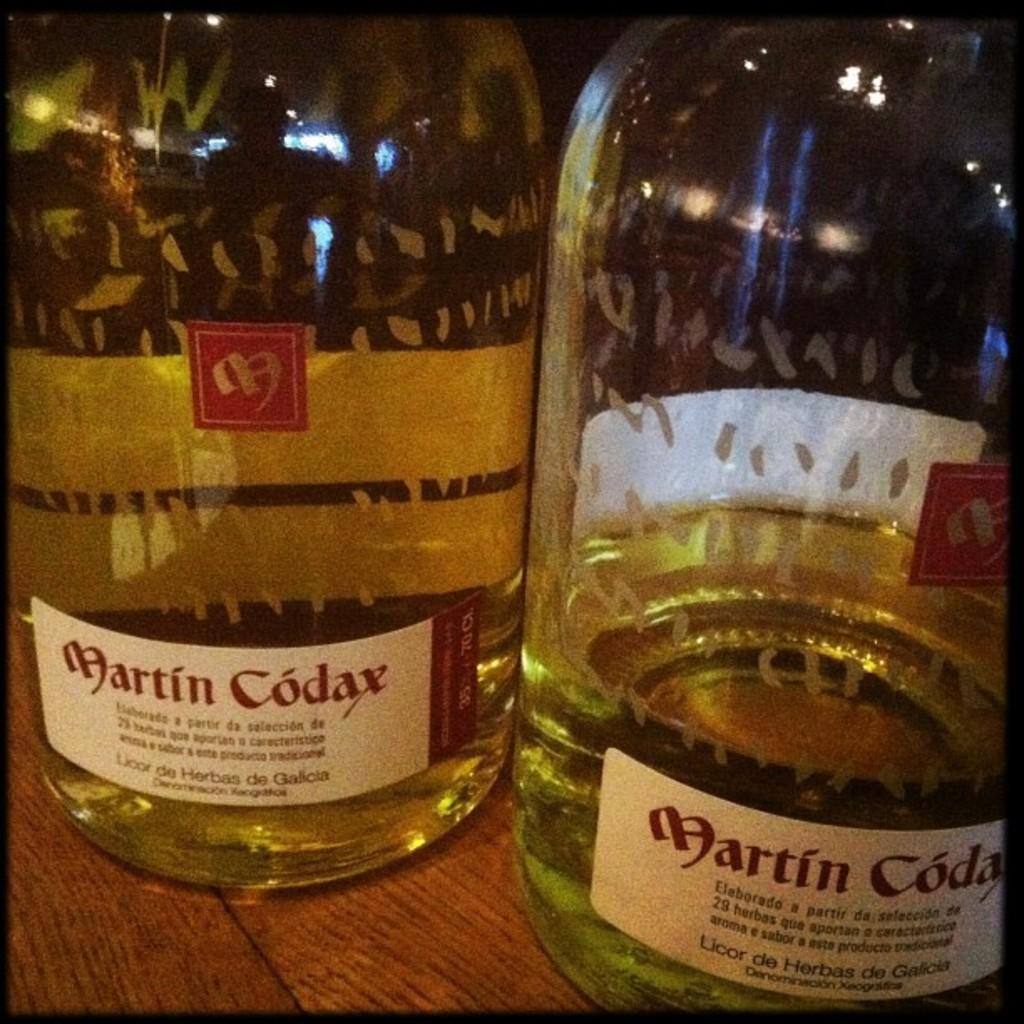<image>
Share a concise interpretation of the image provided. Two bottles of Martin Codax bottles are on a table. 